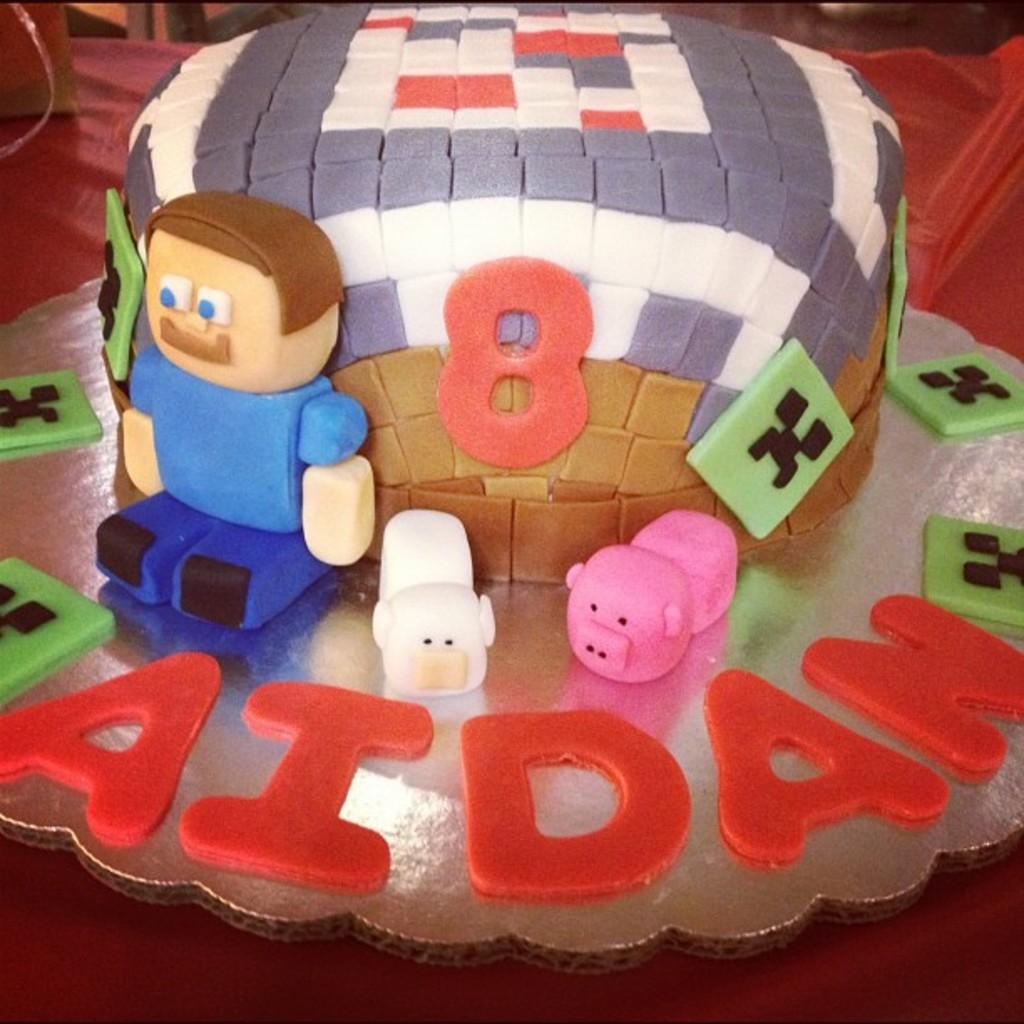What is the main subject of the image? There is a cake in the image. What other items can be seen in the image besides the cake? There are toys in the image. Can you describe an object with a name on it in the image? Yes, there is an object with a name on it in the image. What type of flock can be seen flying over the cake in the image? There is no flock of birds or animals visible in the image. What cord is connected to the cake in the image? There is no cord present in the image. 